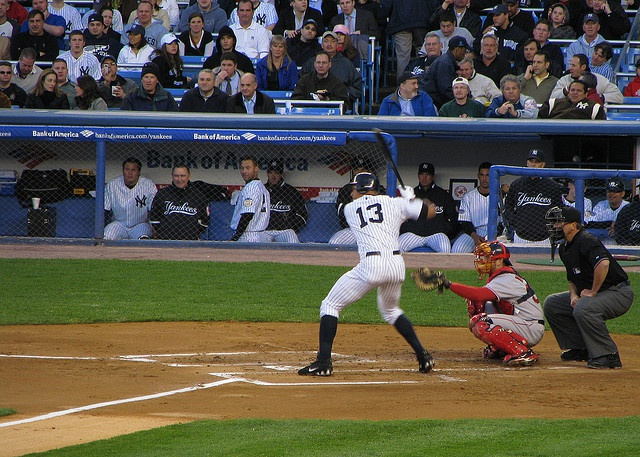Describe the objects in this image and their specific colors. I can see people in gray, black, navy, and darkgray tones, people in gray, lavender, black, and darkgray tones, people in gray, black, and maroon tones, people in gray, darkgray, maroon, black, and brown tones, and people in gray, black, navy, and darkgray tones in this image. 